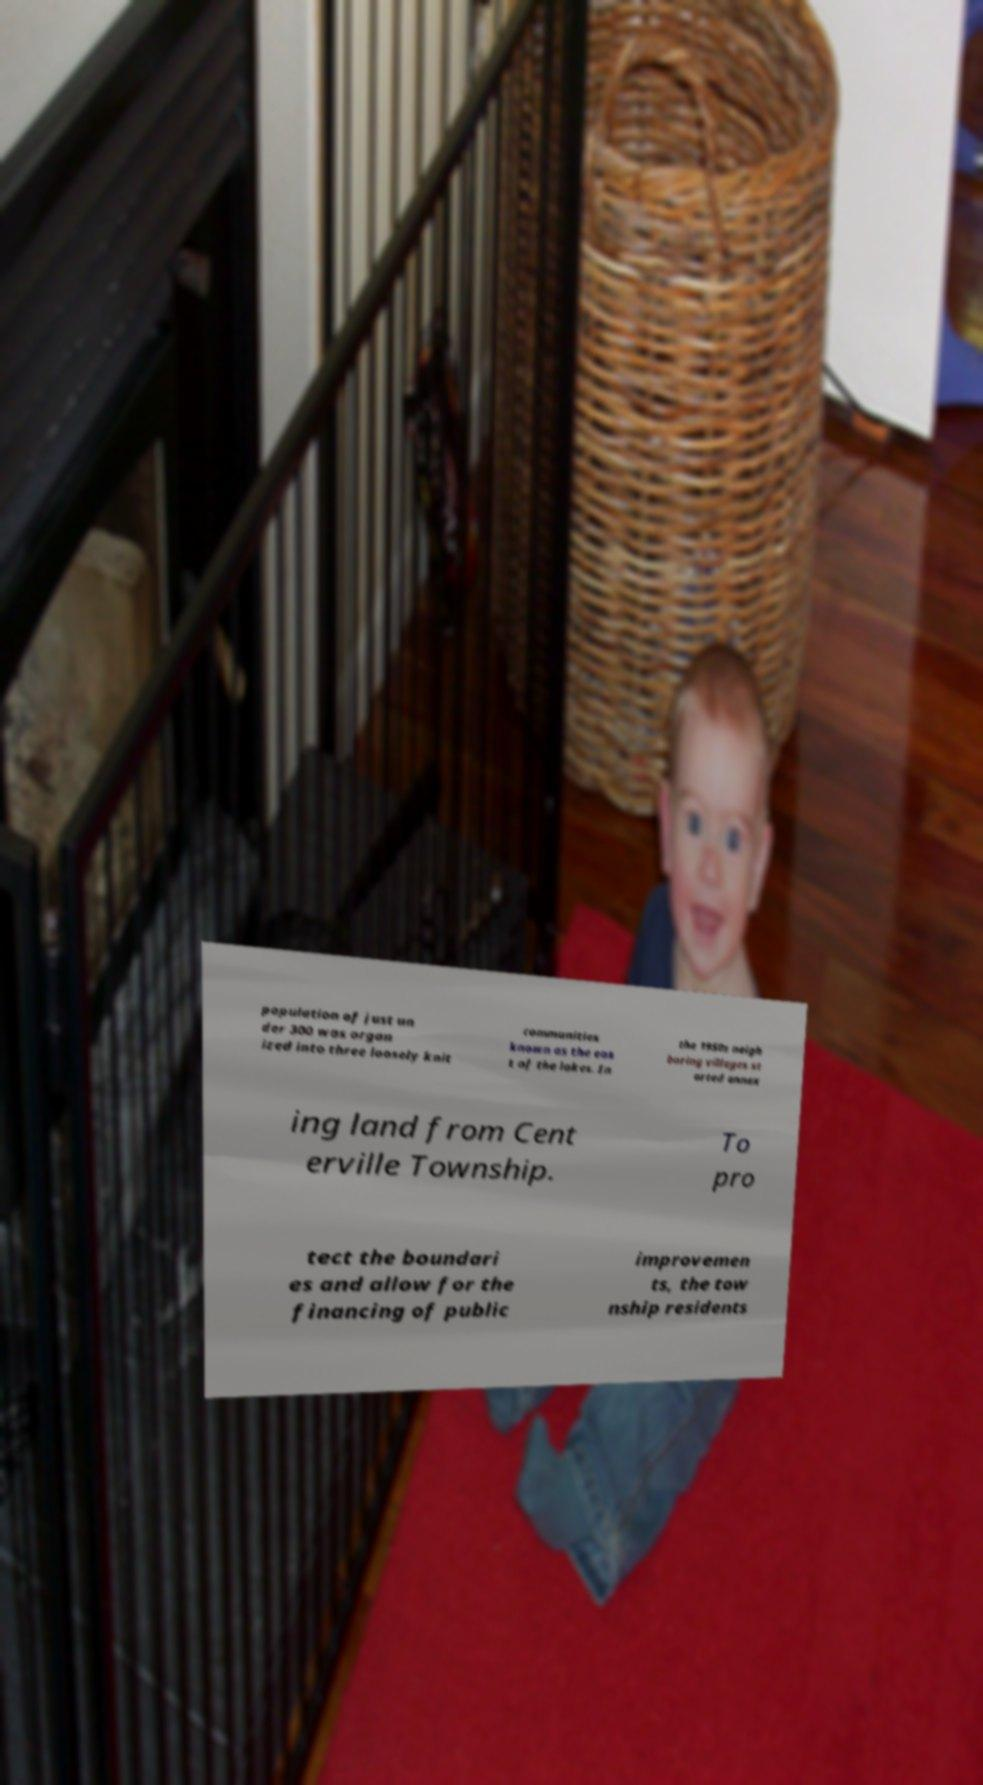There's text embedded in this image that I need extracted. Can you transcribe it verbatim? population of just un der 300 was organ ized into three loosely knit communities known as the eas t of the lakes. In the 1950s neigh boring villages st arted annex ing land from Cent erville Township. To pro tect the boundari es and allow for the financing of public improvemen ts, the tow nship residents 